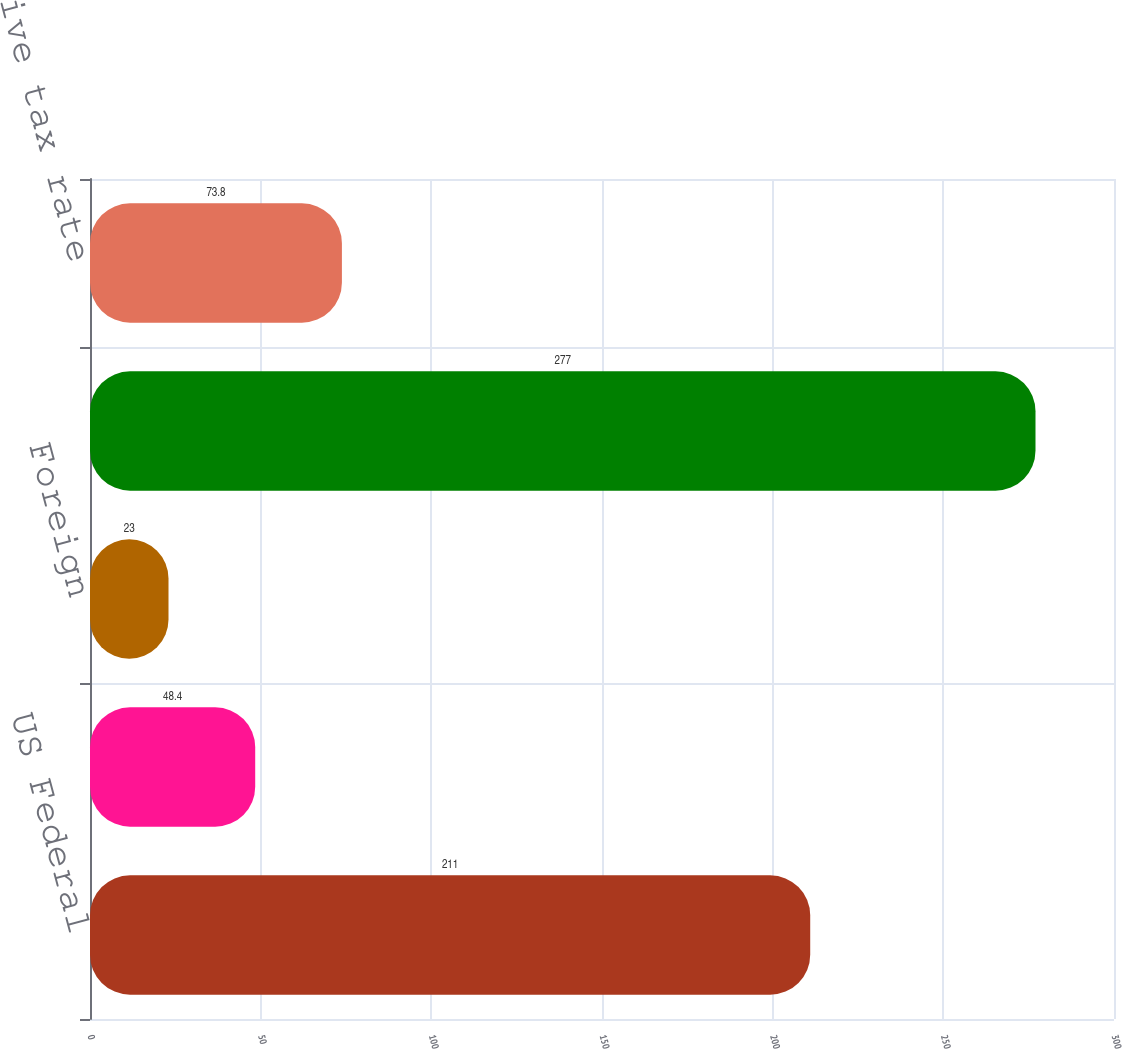<chart> <loc_0><loc_0><loc_500><loc_500><bar_chart><fcel>US Federal<fcel>State<fcel>Foreign<fcel>Total income tax<fcel>Effective tax rate<nl><fcel>211<fcel>48.4<fcel>23<fcel>277<fcel>73.8<nl></chart> 